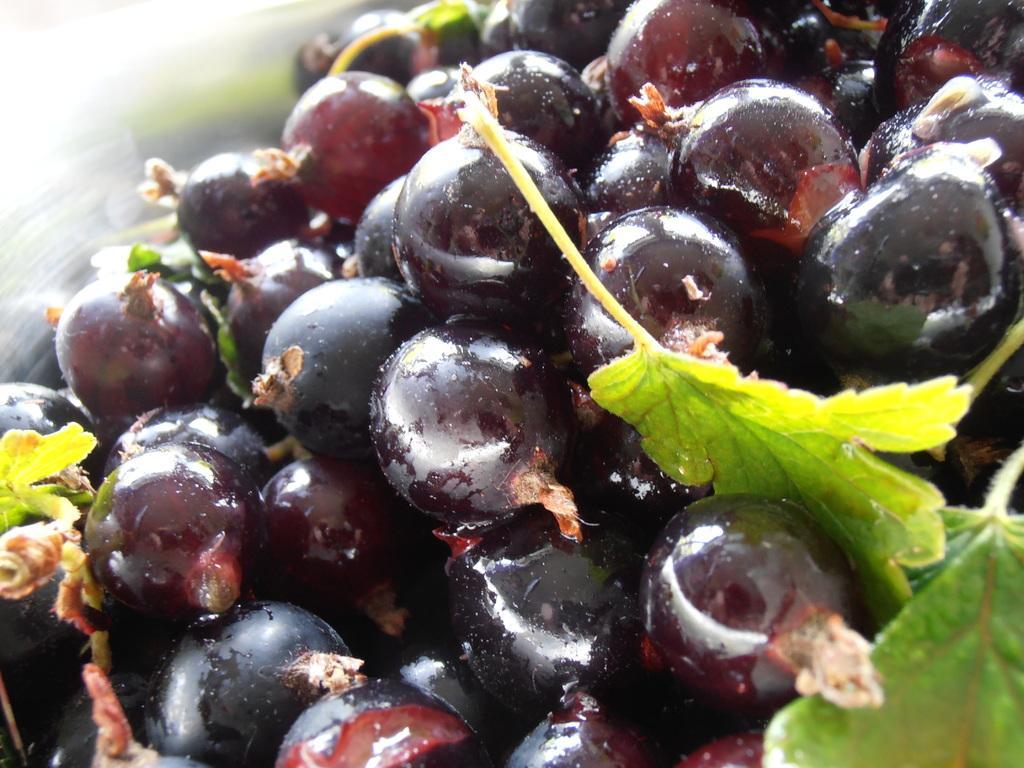Describe this image in one or two sentences. In this image, I can see a bunch of black grapes. These are the leaves. 